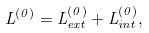<formula> <loc_0><loc_0><loc_500><loc_500>L ^ { ( 0 ) } = L _ { e x t } ^ { ( 0 ) } + L _ { i n t } ^ { ( 0 ) } ,</formula> 